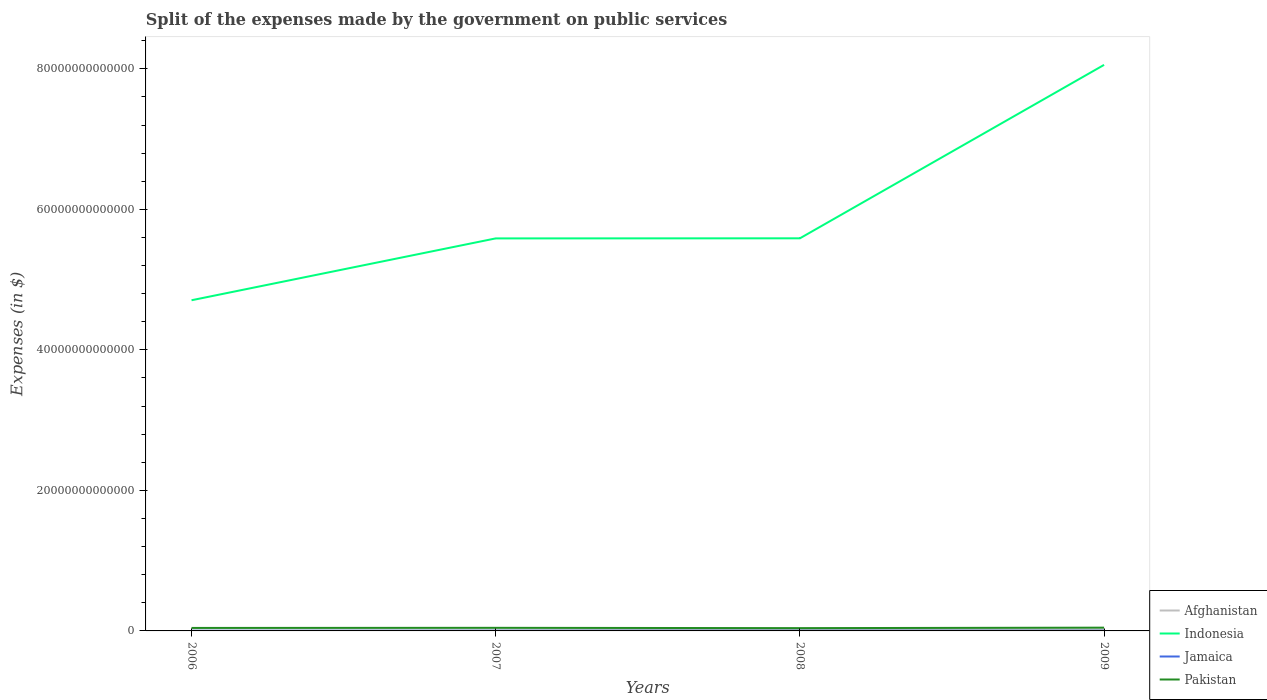Across all years, what is the maximum expenses made by the government on public services in Afghanistan?
Keep it short and to the point. 4.10e+1. In which year was the expenses made by the government on public services in Afghanistan maximum?
Ensure brevity in your answer.  2006. What is the total expenses made by the government on public services in Afghanistan in the graph?
Make the answer very short. -1.48e+11. What is the difference between the highest and the second highest expenses made by the government on public services in Pakistan?
Your answer should be compact. 6.72e+1. How many lines are there?
Your answer should be very brief. 4. How many years are there in the graph?
Ensure brevity in your answer.  4. What is the difference between two consecutive major ticks on the Y-axis?
Provide a succinct answer. 2.00e+13. Does the graph contain any zero values?
Your response must be concise. No. Does the graph contain grids?
Give a very brief answer. No. What is the title of the graph?
Your answer should be very brief. Split of the expenses made by the government on public services. Does "Cote d'Ivoire" appear as one of the legend labels in the graph?
Provide a succinct answer. No. What is the label or title of the X-axis?
Make the answer very short. Years. What is the label or title of the Y-axis?
Your response must be concise. Expenses (in $). What is the Expenses (in $) in Afghanistan in 2006?
Your answer should be very brief. 4.10e+1. What is the Expenses (in $) in Indonesia in 2006?
Your response must be concise. 4.71e+13. What is the Expenses (in $) of Jamaica in 2006?
Your answer should be compact. 1.92e+1. What is the Expenses (in $) in Pakistan in 2006?
Your answer should be compact. 4.25e+11. What is the Expenses (in $) of Afghanistan in 2007?
Make the answer very short. 7.84e+1. What is the Expenses (in $) of Indonesia in 2007?
Your answer should be compact. 5.59e+13. What is the Expenses (in $) in Jamaica in 2007?
Make the answer very short. 2.37e+1. What is the Expenses (in $) in Pakistan in 2007?
Ensure brevity in your answer.  4.41e+11. What is the Expenses (in $) in Afghanistan in 2008?
Offer a very short reply. 1.89e+11. What is the Expenses (in $) in Indonesia in 2008?
Offer a terse response. 5.59e+13. What is the Expenses (in $) of Jamaica in 2008?
Provide a short and direct response. 2.75e+1. What is the Expenses (in $) of Pakistan in 2008?
Make the answer very short. 3.98e+11. What is the Expenses (in $) of Afghanistan in 2009?
Your answer should be very brief. 1.94e+11. What is the Expenses (in $) in Indonesia in 2009?
Offer a very short reply. 8.06e+13. What is the Expenses (in $) of Jamaica in 2009?
Make the answer very short. 2.41e+1. What is the Expenses (in $) in Pakistan in 2009?
Offer a terse response. 4.65e+11. Across all years, what is the maximum Expenses (in $) of Afghanistan?
Ensure brevity in your answer.  1.94e+11. Across all years, what is the maximum Expenses (in $) in Indonesia?
Your answer should be compact. 8.06e+13. Across all years, what is the maximum Expenses (in $) in Jamaica?
Your answer should be very brief. 2.75e+1. Across all years, what is the maximum Expenses (in $) of Pakistan?
Provide a succinct answer. 4.65e+11. Across all years, what is the minimum Expenses (in $) of Afghanistan?
Keep it short and to the point. 4.10e+1. Across all years, what is the minimum Expenses (in $) in Indonesia?
Keep it short and to the point. 4.71e+13. Across all years, what is the minimum Expenses (in $) in Jamaica?
Your answer should be very brief. 1.92e+1. Across all years, what is the minimum Expenses (in $) of Pakistan?
Provide a short and direct response. 3.98e+11. What is the total Expenses (in $) of Afghanistan in the graph?
Provide a succinct answer. 5.03e+11. What is the total Expenses (in $) of Indonesia in the graph?
Ensure brevity in your answer.  2.39e+14. What is the total Expenses (in $) in Jamaica in the graph?
Provide a short and direct response. 9.45e+1. What is the total Expenses (in $) in Pakistan in the graph?
Give a very brief answer. 1.73e+12. What is the difference between the Expenses (in $) in Afghanistan in 2006 and that in 2007?
Make the answer very short. -3.74e+1. What is the difference between the Expenses (in $) in Indonesia in 2006 and that in 2007?
Ensure brevity in your answer.  -8.80e+12. What is the difference between the Expenses (in $) of Jamaica in 2006 and that in 2007?
Make the answer very short. -4.51e+09. What is the difference between the Expenses (in $) in Pakistan in 2006 and that in 2007?
Offer a terse response. -1.57e+1. What is the difference between the Expenses (in $) in Afghanistan in 2006 and that in 2008?
Provide a succinct answer. -1.48e+11. What is the difference between the Expenses (in $) in Indonesia in 2006 and that in 2008?
Keep it short and to the point. -8.81e+12. What is the difference between the Expenses (in $) in Jamaica in 2006 and that in 2008?
Your answer should be very brief. -8.25e+09. What is the difference between the Expenses (in $) of Pakistan in 2006 and that in 2008?
Offer a very short reply. 2.70e+1. What is the difference between the Expenses (in $) of Afghanistan in 2006 and that in 2009?
Your answer should be very brief. -1.53e+11. What is the difference between the Expenses (in $) of Indonesia in 2006 and that in 2009?
Your response must be concise. -3.35e+13. What is the difference between the Expenses (in $) of Jamaica in 2006 and that in 2009?
Your answer should be compact. -4.87e+09. What is the difference between the Expenses (in $) of Pakistan in 2006 and that in 2009?
Keep it short and to the point. -4.02e+1. What is the difference between the Expenses (in $) of Afghanistan in 2007 and that in 2008?
Your answer should be compact. -1.11e+11. What is the difference between the Expenses (in $) of Indonesia in 2007 and that in 2008?
Offer a very short reply. -1.24e+1. What is the difference between the Expenses (in $) in Jamaica in 2007 and that in 2008?
Make the answer very short. -3.74e+09. What is the difference between the Expenses (in $) in Pakistan in 2007 and that in 2008?
Provide a short and direct response. 4.28e+1. What is the difference between the Expenses (in $) in Afghanistan in 2007 and that in 2009?
Offer a terse response. -1.16e+11. What is the difference between the Expenses (in $) of Indonesia in 2007 and that in 2009?
Give a very brief answer. -2.47e+13. What is the difference between the Expenses (in $) of Jamaica in 2007 and that in 2009?
Offer a very short reply. -3.56e+08. What is the difference between the Expenses (in $) of Pakistan in 2007 and that in 2009?
Provide a succinct answer. -2.45e+1. What is the difference between the Expenses (in $) of Afghanistan in 2008 and that in 2009?
Make the answer very short. -5.15e+09. What is the difference between the Expenses (in $) in Indonesia in 2008 and that in 2009?
Give a very brief answer. -2.47e+13. What is the difference between the Expenses (in $) of Jamaica in 2008 and that in 2009?
Provide a short and direct response. 3.39e+09. What is the difference between the Expenses (in $) of Pakistan in 2008 and that in 2009?
Provide a short and direct response. -6.72e+1. What is the difference between the Expenses (in $) of Afghanistan in 2006 and the Expenses (in $) of Indonesia in 2007?
Offer a terse response. -5.58e+13. What is the difference between the Expenses (in $) of Afghanistan in 2006 and the Expenses (in $) of Jamaica in 2007?
Keep it short and to the point. 1.73e+1. What is the difference between the Expenses (in $) of Afghanistan in 2006 and the Expenses (in $) of Pakistan in 2007?
Provide a succinct answer. -4.00e+11. What is the difference between the Expenses (in $) in Indonesia in 2006 and the Expenses (in $) in Jamaica in 2007?
Your response must be concise. 4.70e+13. What is the difference between the Expenses (in $) in Indonesia in 2006 and the Expenses (in $) in Pakistan in 2007?
Your answer should be compact. 4.66e+13. What is the difference between the Expenses (in $) of Jamaica in 2006 and the Expenses (in $) of Pakistan in 2007?
Offer a very short reply. -4.21e+11. What is the difference between the Expenses (in $) of Afghanistan in 2006 and the Expenses (in $) of Indonesia in 2008?
Offer a terse response. -5.58e+13. What is the difference between the Expenses (in $) in Afghanistan in 2006 and the Expenses (in $) in Jamaica in 2008?
Provide a short and direct response. 1.35e+1. What is the difference between the Expenses (in $) of Afghanistan in 2006 and the Expenses (in $) of Pakistan in 2008?
Keep it short and to the point. -3.57e+11. What is the difference between the Expenses (in $) of Indonesia in 2006 and the Expenses (in $) of Jamaica in 2008?
Keep it short and to the point. 4.70e+13. What is the difference between the Expenses (in $) of Indonesia in 2006 and the Expenses (in $) of Pakistan in 2008?
Keep it short and to the point. 4.67e+13. What is the difference between the Expenses (in $) of Jamaica in 2006 and the Expenses (in $) of Pakistan in 2008?
Offer a very short reply. -3.79e+11. What is the difference between the Expenses (in $) in Afghanistan in 2006 and the Expenses (in $) in Indonesia in 2009?
Make the answer very short. -8.05e+13. What is the difference between the Expenses (in $) of Afghanistan in 2006 and the Expenses (in $) of Jamaica in 2009?
Make the answer very short. 1.69e+1. What is the difference between the Expenses (in $) of Afghanistan in 2006 and the Expenses (in $) of Pakistan in 2009?
Keep it short and to the point. -4.24e+11. What is the difference between the Expenses (in $) of Indonesia in 2006 and the Expenses (in $) of Jamaica in 2009?
Your answer should be compact. 4.70e+13. What is the difference between the Expenses (in $) in Indonesia in 2006 and the Expenses (in $) in Pakistan in 2009?
Your answer should be compact. 4.66e+13. What is the difference between the Expenses (in $) of Jamaica in 2006 and the Expenses (in $) of Pakistan in 2009?
Give a very brief answer. -4.46e+11. What is the difference between the Expenses (in $) in Afghanistan in 2007 and the Expenses (in $) in Indonesia in 2008?
Your answer should be compact. -5.58e+13. What is the difference between the Expenses (in $) in Afghanistan in 2007 and the Expenses (in $) in Jamaica in 2008?
Provide a succinct answer. 5.09e+1. What is the difference between the Expenses (in $) of Afghanistan in 2007 and the Expenses (in $) of Pakistan in 2008?
Give a very brief answer. -3.20e+11. What is the difference between the Expenses (in $) in Indonesia in 2007 and the Expenses (in $) in Jamaica in 2008?
Keep it short and to the point. 5.58e+13. What is the difference between the Expenses (in $) in Indonesia in 2007 and the Expenses (in $) in Pakistan in 2008?
Provide a succinct answer. 5.55e+13. What is the difference between the Expenses (in $) in Jamaica in 2007 and the Expenses (in $) in Pakistan in 2008?
Your answer should be very brief. -3.74e+11. What is the difference between the Expenses (in $) in Afghanistan in 2007 and the Expenses (in $) in Indonesia in 2009?
Your response must be concise. -8.05e+13. What is the difference between the Expenses (in $) of Afghanistan in 2007 and the Expenses (in $) of Jamaica in 2009?
Give a very brief answer. 5.43e+1. What is the difference between the Expenses (in $) in Afghanistan in 2007 and the Expenses (in $) in Pakistan in 2009?
Offer a very short reply. -3.87e+11. What is the difference between the Expenses (in $) of Indonesia in 2007 and the Expenses (in $) of Jamaica in 2009?
Provide a short and direct response. 5.58e+13. What is the difference between the Expenses (in $) of Indonesia in 2007 and the Expenses (in $) of Pakistan in 2009?
Your answer should be compact. 5.54e+13. What is the difference between the Expenses (in $) of Jamaica in 2007 and the Expenses (in $) of Pakistan in 2009?
Offer a very short reply. -4.41e+11. What is the difference between the Expenses (in $) in Afghanistan in 2008 and the Expenses (in $) in Indonesia in 2009?
Your response must be concise. -8.04e+13. What is the difference between the Expenses (in $) of Afghanistan in 2008 and the Expenses (in $) of Jamaica in 2009?
Offer a very short reply. 1.65e+11. What is the difference between the Expenses (in $) of Afghanistan in 2008 and the Expenses (in $) of Pakistan in 2009?
Your answer should be very brief. -2.76e+11. What is the difference between the Expenses (in $) of Indonesia in 2008 and the Expenses (in $) of Jamaica in 2009?
Your answer should be compact. 5.59e+13. What is the difference between the Expenses (in $) in Indonesia in 2008 and the Expenses (in $) in Pakistan in 2009?
Give a very brief answer. 5.54e+13. What is the difference between the Expenses (in $) in Jamaica in 2008 and the Expenses (in $) in Pakistan in 2009?
Your answer should be compact. -4.38e+11. What is the average Expenses (in $) in Afghanistan per year?
Give a very brief answer. 1.26e+11. What is the average Expenses (in $) in Indonesia per year?
Your answer should be compact. 5.98e+13. What is the average Expenses (in $) in Jamaica per year?
Your response must be concise. 2.36e+1. What is the average Expenses (in $) of Pakistan per year?
Ensure brevity in your answer.  4.32e+11. In the year 2006, what is the difference between the Expenses (in $) in Afghanistan and Expenses (in $) in Indonesia?
Ensure brevity in your answer.  -4.70e+13. In the year 2006, what is the difference between the Expenses (in $) of Afghanistan and Expenses (in $) of Jamaica?
Ensure brevity in your answer.  2.18e+1. In the year 2006, what is the difference between the Expenses (in $) in Afghanistan and Expenses (in $) in Pakistan?
Offer a terse response. -3.84e+11. In the year 2006, what is the difference between the Expenses (in $) in Indonesia and Expenses (in $) in Jamaica?
Your answer should be compact. 4.70e+13. In the year 2006, what is the difference between the Expenses (in $) of Indonesia and Expenses (in $) of Pakistan?
Your response must be concise. 4.66e+13. In the year 2006, what is the difference between the Expenses (in $) of Jamaica and Expenses (in $) of Pakistan?
Provide a succinct answer. -4.06e+11. In the year 2007, what is the difference between the Expenses (in $) of Afghanistan and Expenses (in $) of Indonesia?
Offer a very short reply. -5.58e+13. In the year 2007, what is the difference between the Expenses (in $) of Afghanistan and Expenses (in $) of Jamaica?
Your response must be concise. 5.46e+1. In the year 2007, what is the difference between the Expenses (in $) in Afghanistan and Expenses (in $) in Pakistan?
Provide a succinct answer. -3.62e+11. In the year 2007, what is the difference between the Expenses (in $) in Indonesia and Expenses (in $) in Jamaica?
Your answer should be very brief. 5.58e+13. In the year 2007, what is the difference between the Expenses (in $) of Indonesia and Expenses (in $) of Pakistan?
Your response must be concise. 5.54e+13. In the year 2007, what is the difference between the Expenses (in $) of Jamaica and Expenses (in $) of Pakistan?
Your answer should be compact. -4.17e+11. In the year 2008, what is the difference between the Expenses (in $) in Afghanistan and Expenses (in $) in Indonesia?
Provide a succinct answer. -5.57e+13. In the year 2008, what is the difference between the Expenses (in $) in Afghanistan and Expenses (in $) in Jamaica?
Offer a very short reply. 1.62e+11. In the year 2008, what is the difference between the Expenses (in $) of Afghanistan and Expenses (in $) of Pakistan?
Provide a succinct answer. -2.09e+11. In the year 2008, what is the difference between the Expenses (in $) in Indonesia and Expenses (in $) in Jamaica?
Your answer should be compact. 5.59e+13. In the year 2008, what is the difference between the Expenses (in $) of Indonesia and Expenses (in $) of Pakistan?
Your answer should be compact. 5.55e+13. In the year 2008, what is the difference between the Expenses (in $) of Jamaica and Expenses (in $) of Pakistan?
Your answer should be compact. -3.70e+11. In the year 2009, what is the difference between the Expenses (in $) of Afghanistan and Expenses (in $) of Indonesia?
Provide a succinct answer. -8.04e+13. In the year 2009, what is the difference between the Expenses (in $) of Afghanistan and Expenses (in $) of Jamaica?
Offer a very short reply. 1.70e+11. In the year 2009, what is the difference between the Expenses (in $) of Afghanistan and Expenses (in $) of Pakistan?
Your answer should be very brief. -2.71e+11. In the year 2009, what is the difference between the Expenses (in $) in Indonesia and Expenses (in $) in Jamaica?
Ensure brevity in your answer.  8.05e+13. In the year 2009, what is the difference between the Expenses (in $) in Indonesia and Expenses (in $) in Pakistan?
Provide a short and direct response. 8.01e+13. In the year 2009, what is the difference between the Expenses (in $) in Jamaica and Expenses (in $) in Pakistan?
Provide a short and direct response. -4.41e+11. What is the ratio of the Expenses (in $) of Afghanistan in 2006 to that in 2007?
Offer a terse response. 0.52. What is the ratio of the Expenses (in $) of Indonesia in 2006 to that in 2007?
Offer a very short reply. 0.84. What is the ratio of the Expenses (in $) of Jamaica in 2006 to that in 2007?
Your answer should be very brief. 0.81. What is the ratio of the Expenses (in $) in Afghanistan in 2006 to that in 2008?
Your answer should be very brief. 0.22. What is the ratio of the Expenses (in $) in Indonesia in 2006 to that in 2008?
Offer a terse response. 0.84. What is the ratio of the Expenses (in $) in Jamaica in 2006 to that in 2008?
Make the answer very short. 0.7. What is the ratio of the Expenses (in $) of Pakistan in 2006 to that in 2008?
Provide a succinct answer. 1.07. What is the ratio of the Expenses (in $) in Afghanistan in 2006 to that in 2009?
Provide a succinct answer. 0.21. What is the ratio of the Expenses (in $) of Indonesia in 2006 to that in 2009?
Your response must be concise. 0.58. What is the ratio of the Expenses (in $) in Jamaica in 2006 to that in 2009?
Provide a succinct answer. 0.8. What is the ratio of the Expenses (in $) of Pakistan in 2006 to that in 2009?
Give a very brief answer. 0.91. What is the ratio of the Expenses (in $) in Afghanistan in 2007 to that in 2008?
Your answer should be very brief. 0.41. What is the ratio of the Expenses (in $) of Jamaica in 2007 to that in 2008?
Offer a terse response. 0.86. What is the ratio of the Expenses (in $) of Pakistan in 2007 to that in 2008?
Offer a terse response. 1.11. What is the ratio of the Expenses (in $) in Afghanistan in 2007 to that in 2009?
Offer a very short reply. 0.4. What is the ratio of the Expenses (in $) in Indonesia in 2007 to that in 2009?
Your response must be concise. 0.69. What is the ratio of the Expenses (in $) in Jamaica in 2007 to that in 2009?
Your answer should be compact. 0.99. What is the ratio of the Expenses (in $) of Afghanistan in 2008 to that in 2009?
Ensure brevity in your answer.  0.97. What is the ratio of the Expenses (in $) in Indonesia in 2008 to that in 2009?
Offer a terse response. 0.69. What is the ratio of the Expenses (in $) of Jamaica in 2008 to that in 2009?
Your answer should be very brief. 1.14. What is the ratio of the Expenses (in $) of Pakistan in 2008 to that in 2009?
Give a very brief answer. 0.86. What is the difference between the highest and the second highest Expenses (in $) of Afghanistan?
Your answer should be very brief. 5.15e+09. What is the difference between the highest and the second highest Expenses (in $) in Indonesia?
Keep it short and to the point. 2.47e+13. What is the difference between the highest and the second highest Expenses (in $) in Jamaica?
Offer a very short reply. 3.39e+09. What is the difference between the highest and the second highest Expenses (in $) of Pakistan?
Keep it short and to the point. 2.45e+1. What is the difference between the highest and the lowest Expenses (in $) of Afghanistan?
Provide a succinct answer. 1.53e+11. What is the difference between the highest and the lowest Expenses (in $) in Indonesia?
Give a very brief answer. 3.35e+13. What is the difference between the highest and the lowest Expenses (in $) in Jamaica?
Provide a short and direct response. 8.25e+09. What is the difference between the highest and the lowest Expenses (in $) of Pakistan?
Your answer should be very brief. 6.72e+1. 